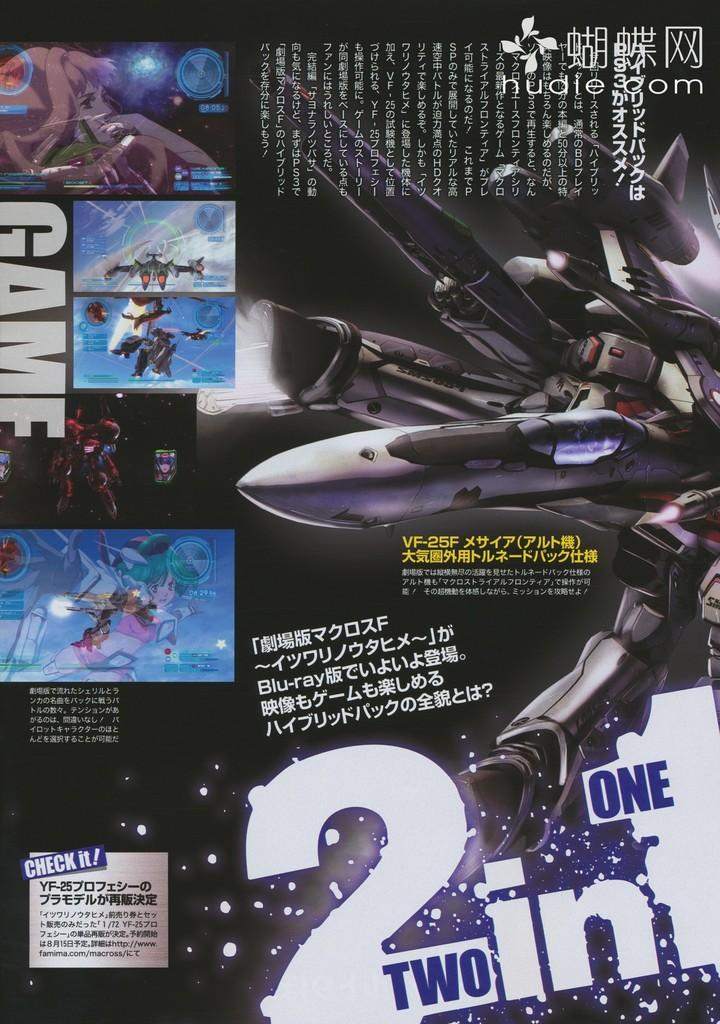Provide a one-sentence caption for the provided image. An add that says two in one with multiple images. 